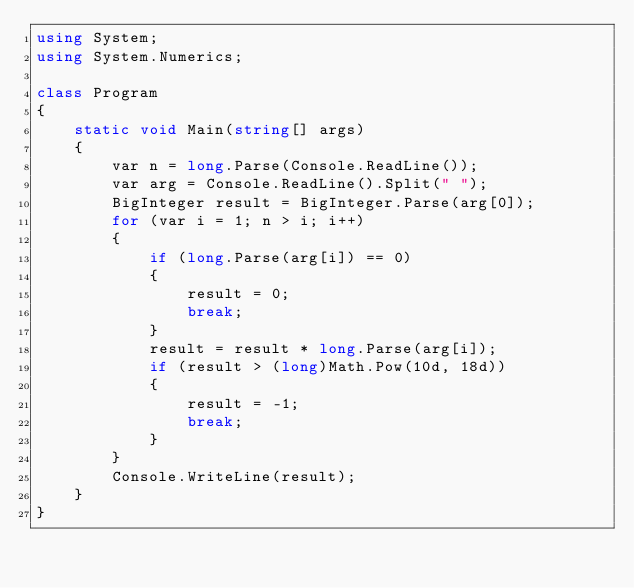<code> <loc_0><loc_0><loc_500><loc_500><_C#_>using System;
using System.Numerics;

class Program
{
    static void Main(string[] args)
    {
        var n = long.Parse(Console.ReadLine());
        var arg = Console.ReadLine().Split(" ");
        BigInteger result = BigInteger.Parse(arg[0]);
        for (var i = 1; n > i; i++)
        {
            if (long.Parse(arg[i]) == 0)
            {
                result = 0;
                break;
            }
            result = result * long.Parse(arg[i]);
            if (result > (long)Math.Pow(10d, 18d))
            {
                result = -1;
                break;
            }
        }
        Console.WriteLine(result);
    }
}</code> 